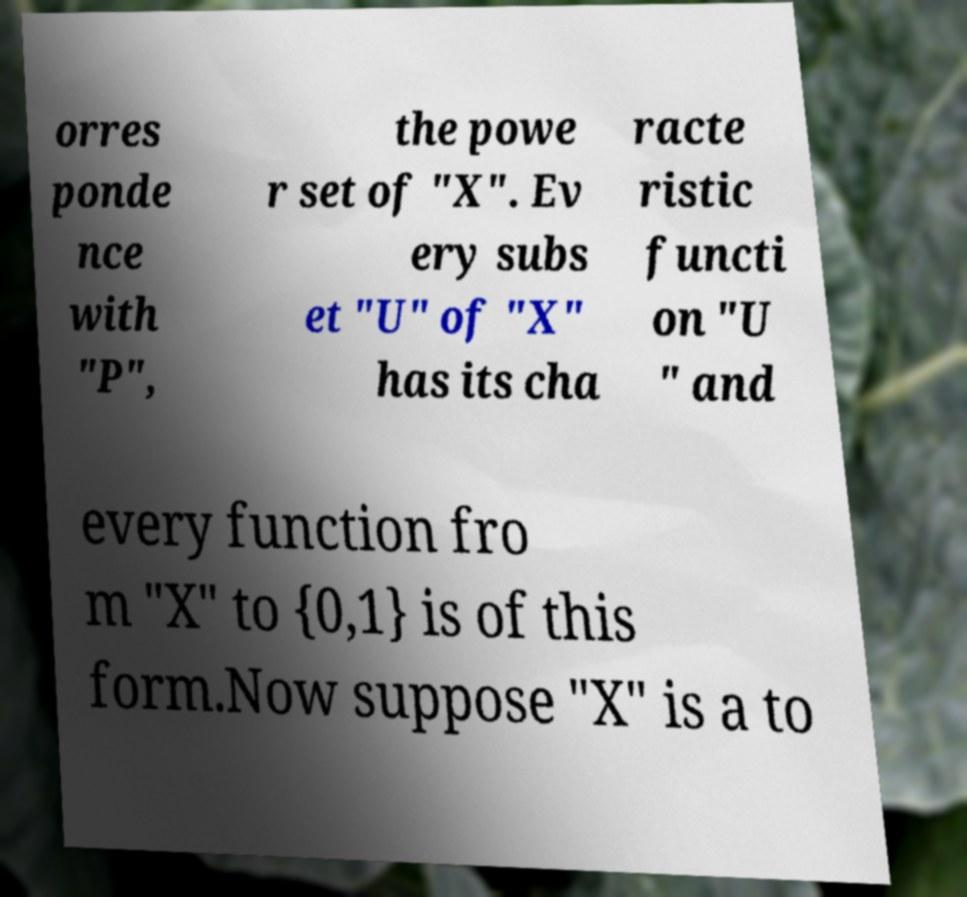What messages or text are displayed in this image? I need them in a readable, typed format. orres ponde nce with "P", the powe r set of "X". Ev ery subs et "U" of "X" has its cha racte ristic functi on "U " and every function fro m "X" to {0,1} is of this form.Now suppose "X" is a to 